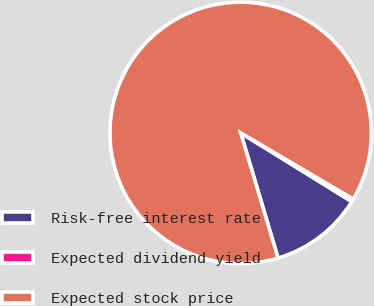Convert chart to OTSL. <chart><loc_0><loc_0><loc_500><loc_500><pie_chart><fcel>Risk-free interest rate<fcel>Expected dividend yield<fcel>Expected stock price<nl><fcel>11.57%<fcel>0.35%<fcel>88.09%<nl></chart> 